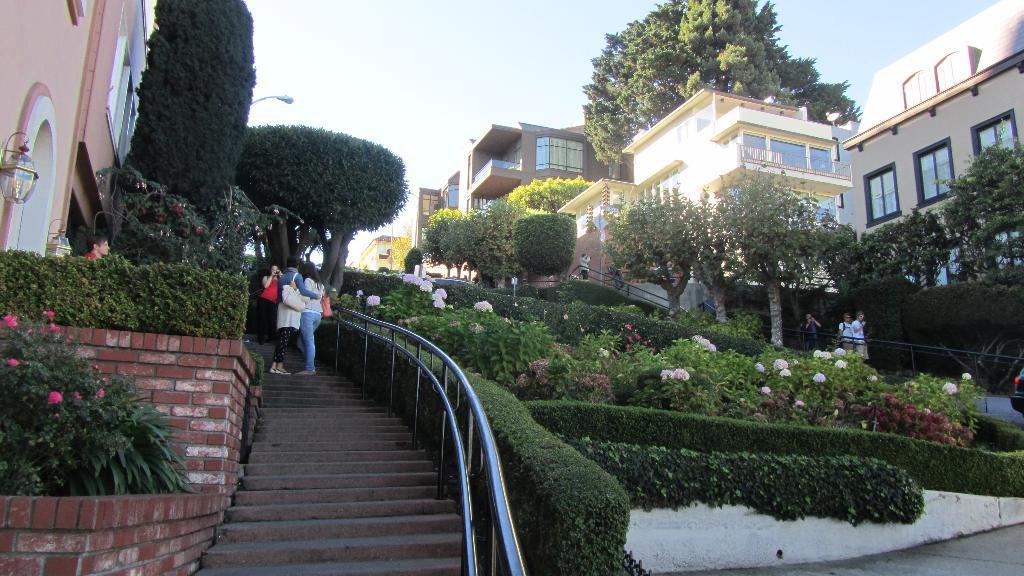Please provide a concise description of this image. In this image we can see a few people on the staircases, among them some people are carrying the bags, there are some plants, flowers, trees, buildings, grille, lights and windows, in the background we can see the sky. 